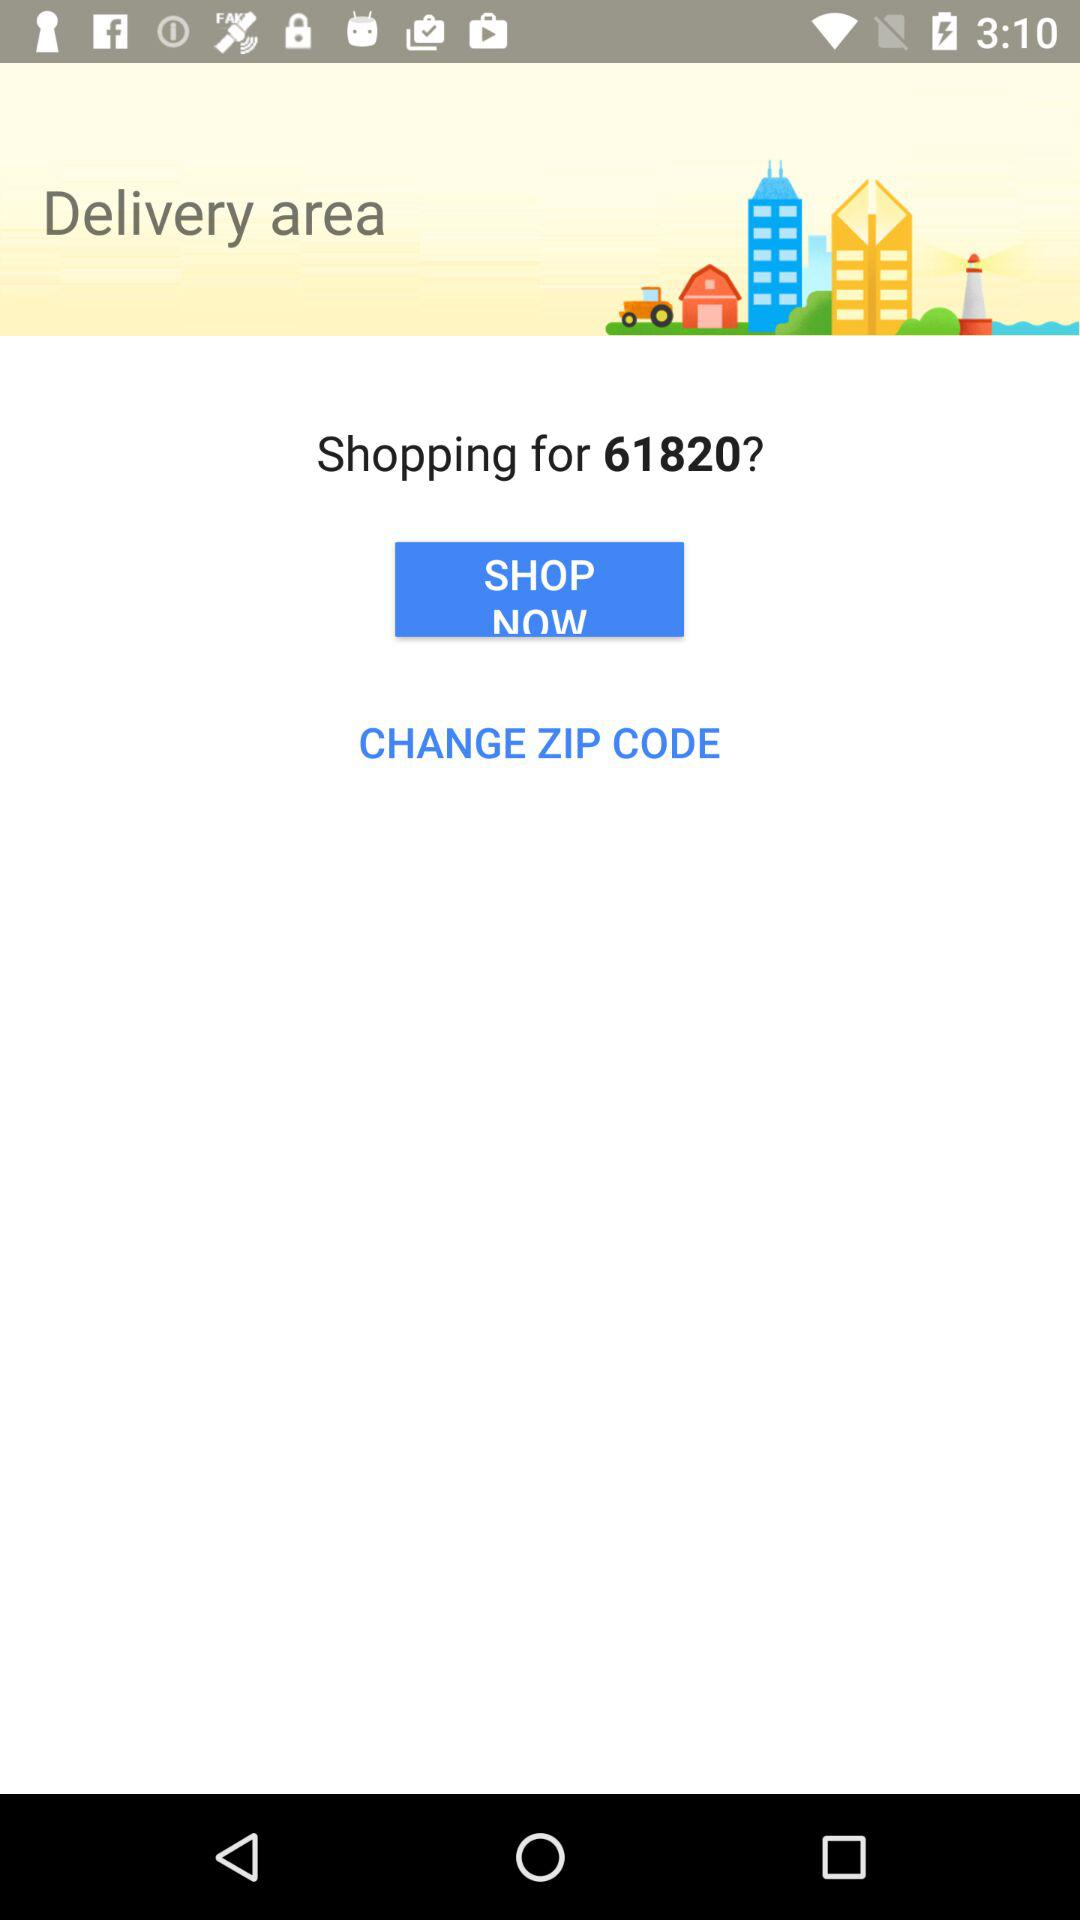What is the given zip code? The given zip code is 61820. 